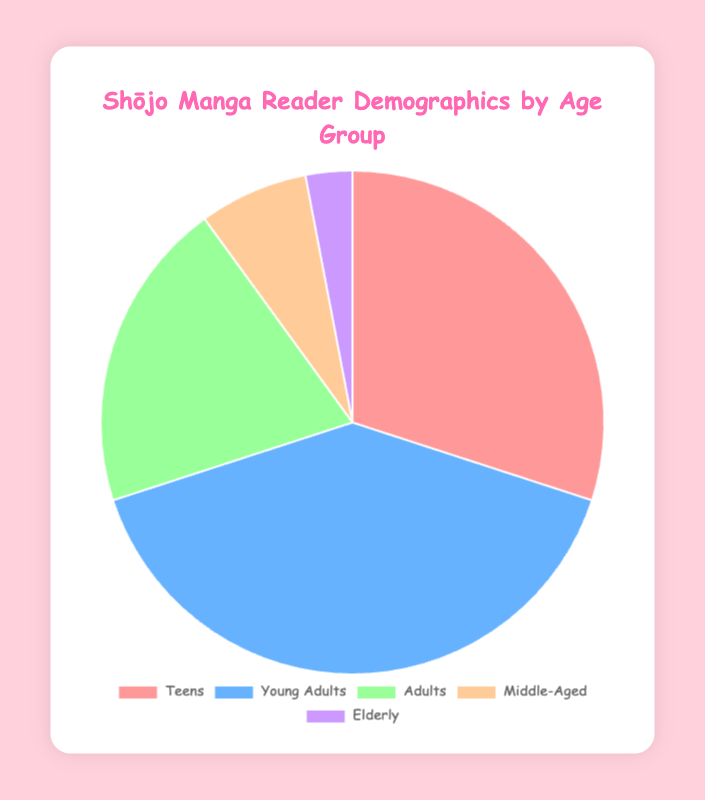What percentage of readers are either Teens or Young Adults? Summing the percentages for Teens and Young Adults: 30% + 40% = 70%
Answer: 70% Which age group has the largest percentage of readers? The age group with the largest percentage is identified by looking at the maximum value among the percentages. Young Adults have the highest percentage at 40%.
Answer: Young Adults What is the total percentage of readers in the Adults and Middle-Aged categories? Adding the percentages for Adults and Middle-Aged: 20% + 7% = 27%
Answer: 27% Is the percentage of Elderly readers less than 5%? The percentage of Elderly readers is 3%, which is less than 5%.
Answer: Yes How much more percentage do Teens and Adults have combined compared to Middle-Aged and Elderly combined? Combining Teens and Adults: 30% + 20% = 50%, and combining Middle-Aged and Elderly: 7% + 3% = 10%. The difference is 50% - 10% = 40%.
Answer: 40% What are the colors used to represent the age groups in the chart? The colors representing the age groups are visually identified. Teens: Pink, Young Adults: Blue, Adults: Green, Middle-Aged: Peach, Elderly: Purple.
Answer: Pink, Blue, Green, Peach, Purple By how much percentage does the Young Adult category exceed the Adult category? The difference in percentages between Young Adults and Adults is calculated by subtracting Adult percentage from Young Adult percentage: 40% - 20% = 20%.
Answer: 20% Which two age groups combined make up 50% exactly? From the data: Teens (30%) and Adults (20%) when combined equal 30% + 20% = 50%.
Answer: Teens and Adults 